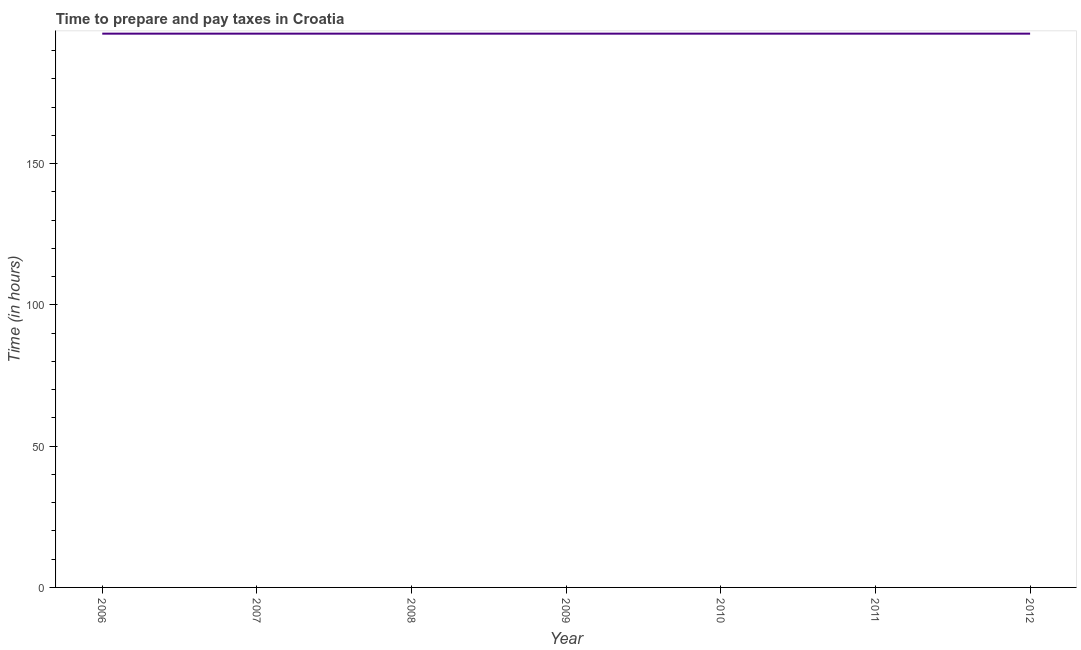What is the time to prepare and pay taxes in 2012?
Provide a short and direct response. 196. Across all years, what is the maximum time to prepare and pay taxes?
Your answer should be compact. 196. Across all years, what is the minimum time to prepare and pay taxes?
Your response must be concise. 196. In which year was the time to prepare and pay taxes minimum?
Provide a short and direct response. 2006. What is the sum of the time to prepare and pay taxes?
Keep it short and to the point. 1372. What is the difference between the time to prepare and pay taxes in 2006 and 2010?
Offer a very short reply. 0. What is the average time to prepare and pay taxes per year?
Give a very brief answer. 196. What is the median time to prepare and pay taxes?
Keep it short and to the point. 196. In how many years, is the time to prepare and pay taxes greater than 10 hours?
Provide a succinct answer. 7. Do a majority of the years between 2009 and 2011 (inclusive) have time to prepare and pay taxes greater than 60 hours?
Your response must be concise. Yes. What is the difference between the highest and the lowest time to prepare and pay taxes?
Your answer should be very brief. 0. How many lines are there?
Your answer should be very brief. 1. What is the difference between two consecutive major ticks on the Y-axis?
Ensure brevity in your answer.  50. Does the graph contain any zero values?
Your answer should be compact. No. What is the title of the graph?
Provide a succinct answer. Time to prepare and pay taxes in Croatia. What is the label or title of the X-axis?
Provide a succinct answer. Year. What is the label or title of the Y-axis?
Provide a short and direct response. Time (in hours). What is the Time (in hours) in 2006?
Your answer should be compact. 196. What is the Time (in hours) of 2007?
Offer a terse response. 196. What is the Time (in hours) in 2008?
Your answer should be very brief. 196. What is the Time (in hours) in 2009?
Offer a terse response. 196. What is the Time (in hours) of 2010?
Offer a terse response. 196. What is the Time (in hours) of 2011?
Provide a succinct answer. 196. What is the Time (in hours) in 2012?
Keep it short and to the point. 196. What is the difference between the Time (in hours) in 2006 and 2007?
Offer a very short reply. 0. What is the difference between the Time (in hours) in 2006 and 2009?
Make the answer very short. 0. What is the difference between the Time (in hours) in 2006 and 2011?
Your answer should be compact. 0. What is the difference between the Time (in hours) in 2006 and 2012?
Your response must be concise. 0. What is the difference between the Time (in hours) in 2007 and 2008?
Provide a succinct answer. 0. What is the difference between the Time (in hours) in 2008 and 2011?
Offer a terse response. 0. What is the difference between the Time (in hours) in 2008 and 2012?
Ensure brevity in your answer.  0. What is the difference between the Time (in hours) in 2009 and 2010?
Your answer should be very brief. 0. What is the difference between the Time (in hours) in 2009 and 2011?
Make the answer very short. 0. What is the difference between the Time (in hours) in 2009 and 2012?
Offer a very short reply. 0. What is the difference between the Time (in hours) in 2010 and 2011?
Offer a very short reply. 0. What is the difference between the Time (in hours) in 2011 and 2012?
Provide a short and direct response. 0. What is the ratio of the Time (in hours) in 2006 to that in 2007?
Your answer should be compact. 1. What is the ratio of the Time (in hours) in 2006 to that in 2008?
Your response must be concise. 1. What is the ratio of the Time (in hours) in 2006 to that in 2009?
Keep it short and to the point. 1. What is the ratio of the Time (in hours) in 2006 to that in 2012?
Provide a short and direct response. 1. What is the ratio of the Time (in hours) in 2007 to that in 2008?
Ensure brevity in your answer.  1. What is the ratio of the Time (in hours) in 2008 to that in 2010?
Keep it short and to the point. 1. What is the ratio of the Time (in hours) in 2008 to that in 2011?
Provide a short and direct response. 1. What is the ratio of the Time (in hours) in 2008 to that in 2012?
Make the answer very short. 1. What is the ratio of the Time (in hours) in 2009 to that in 2010?
Provide a succinct answer. 1. What is the ratio of the Time (in hours) in 2009 to that in 2011?
Provide a succinct answer. 1. 